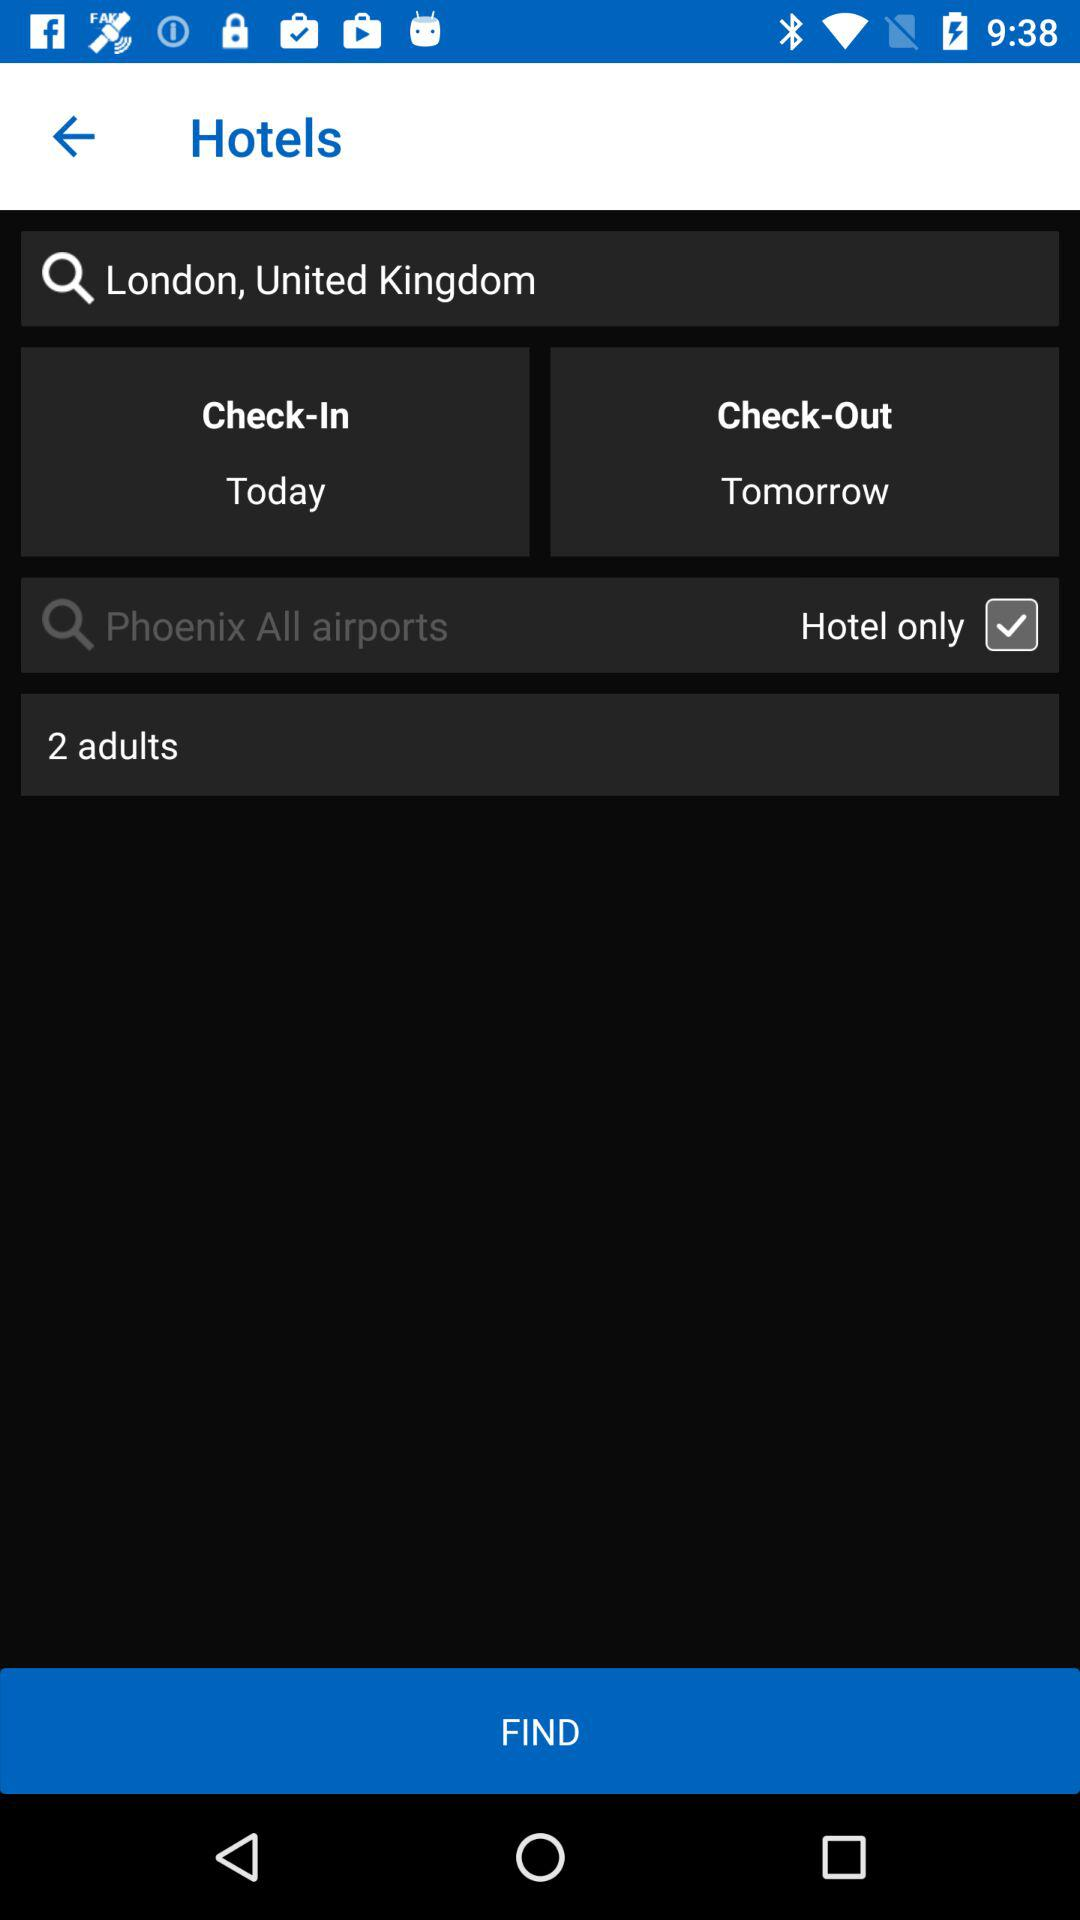What is the location? The location is London, United Kingdom. 